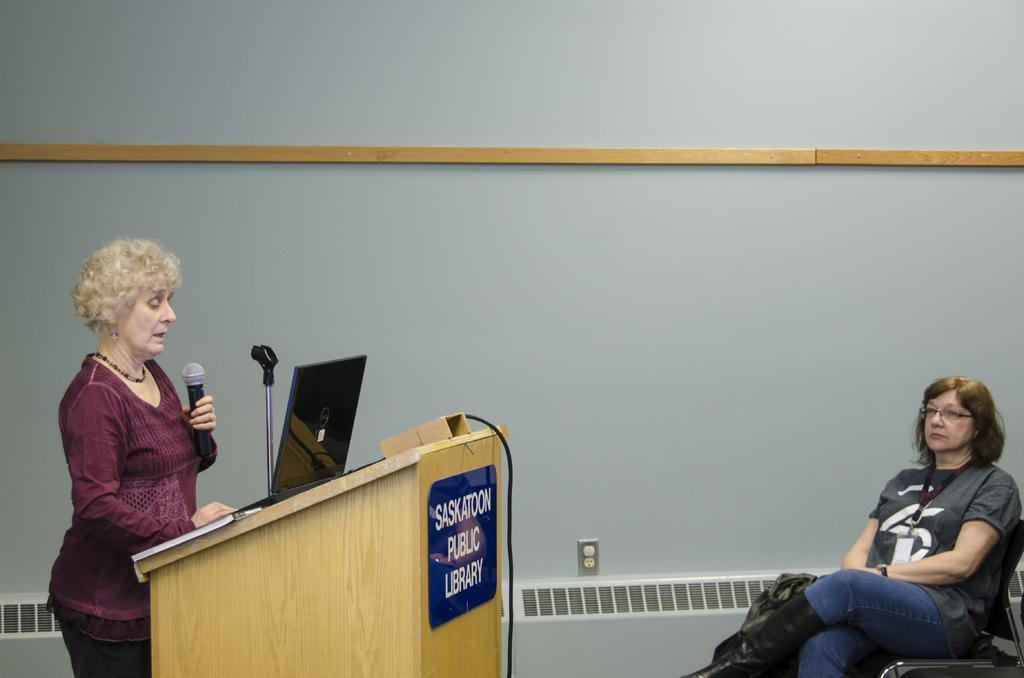How many people are in the image? There are two ladies in the image. What are the positions of the ladies in the image? One lady is sitting on a chair, and the other lady is standing in front of a desk. What objects can be seen on the desk? There is a mic and a laptop on the desk. How many frogs are sitting on the chair with the lady? There are no frogs present in the image. What is the relation between the two ladies in the image? The provided facts do not give any information about the relationship between the two ladies. 